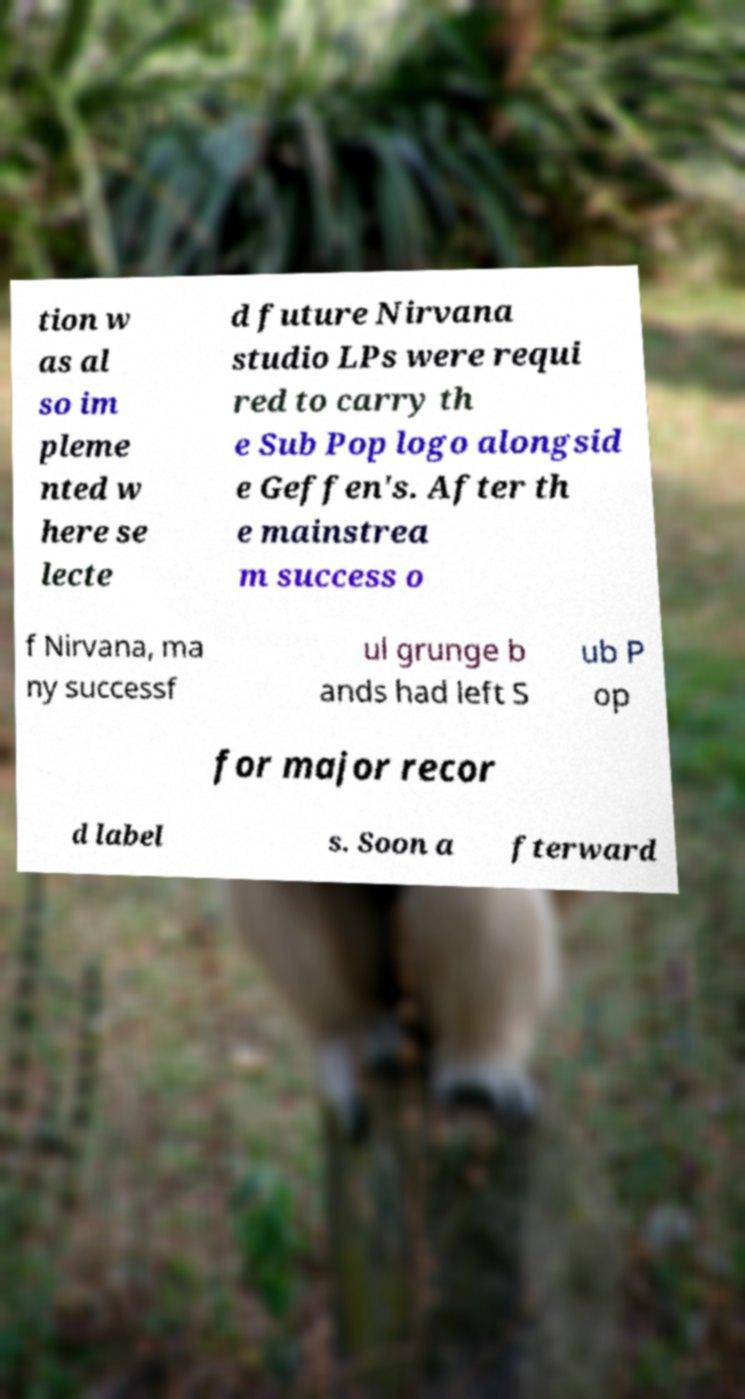There's text embedded in this image that I need extracted. Can you transcribe it verbatim? tion w as al so im pleme nted w here se lecte d future Nirvana studio LPs were requi red to carry th e Sub Pop logo alongsid e Geffen's. After th e mainstrea m success o f Nirvana, ma ny successf ul grunge b ands had left S ub P op for major recor d label s. Soon a fterward 